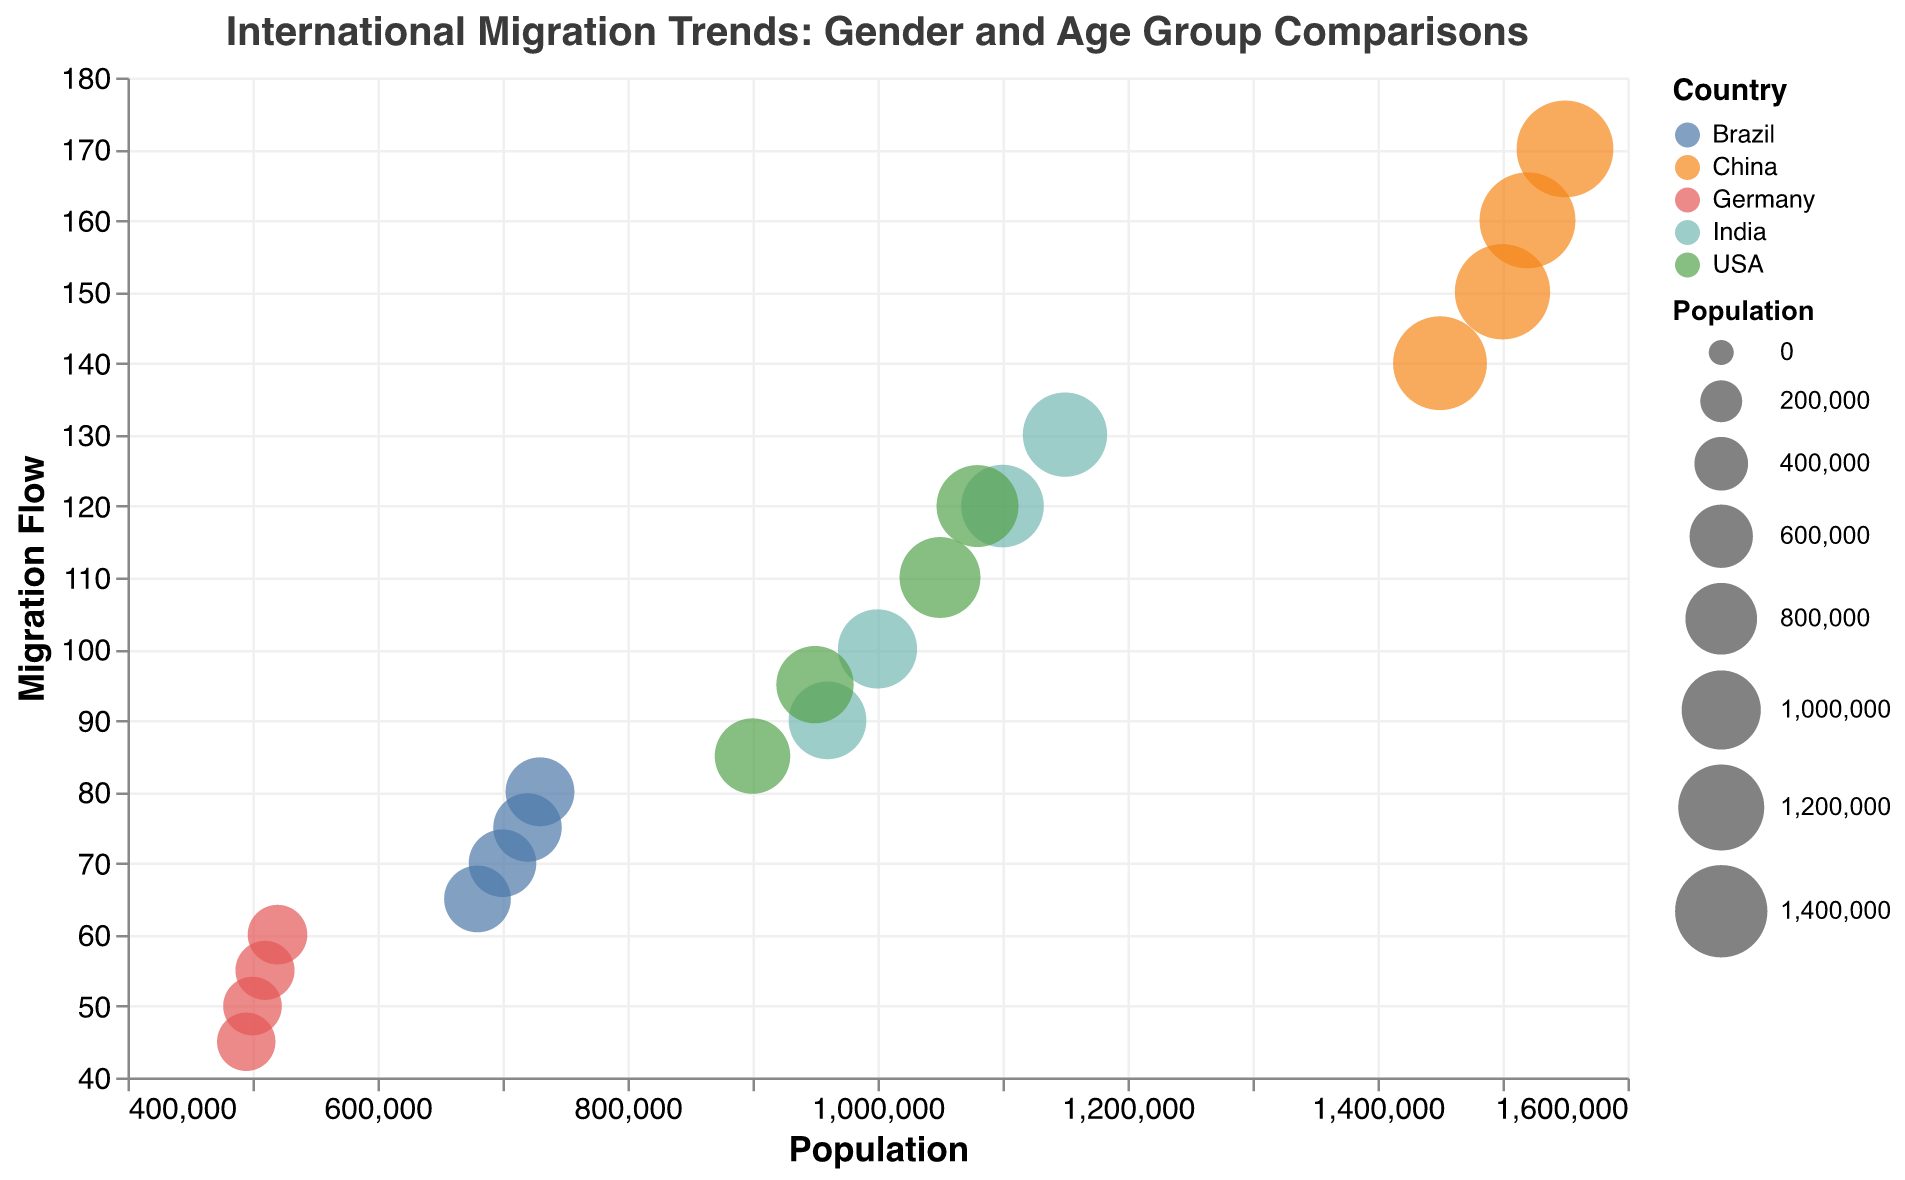What is the title of the figure? The title is displayed at the top of the figure and reads "International Migration Trends: Gender and Age Group Comparisons".
Answer: International Migration Trends: Gender and Age Group Comparisons How many different countries are represented in the chart? By examining the color legend, there are different colors representing each country, and we can visually count the different items in the legend.
Answer: 5 What does the shape of each bubble represent? According to the legend, the shape indicates the gender where circles represent males and squares represent females.
Answer: Gender In the age group 15-24, which country has the highest migration flow for males? Focusing on the bubbles with circle shapes (male) and the y-axis labeled 15-24, we see China at the topmost point.
Answer: China How does the migration flow for females compare between age groups 15-24 and 25-34 in the USA? For females in the USA (squares), the bubbles are placed around 85 for 15-24 and 120 for 25-34 along the y-axis, indicating a higher migration flow for the 25-34 age group.
Answer: Higher in 25-34 Which country has the largest size bubble for the age group 25-34 regardless of gender? Looking at both shapes in the age group 25-34, the largest bubbles representing the population size are from China.
Answer: China What pattern can be observed in the migration flow of females across different countries? The positioning and size of the square shape bubbles indicate that migration flow generally increases from Germany, Brazil, USA, India to China. This trend follows the size of the bubbles as well which represent populations.
Answer: Increasing trend from Germany to China What is the relationship between population size and migration flow as depicted in the figure? Analyzing the placements of bubbles, bubbles further to the right (larger populations) tend to be higher up (higher migration flow), indicating a positive correlation.
Answer: Positive correlation Between India and Brazil, which country has a higher migration flow for males aged 25-34? By comparing the corresponding bubbles for males (circles) in these age groups, India's bubble is higher on the y-axis than Brazil's.
Answer: India 